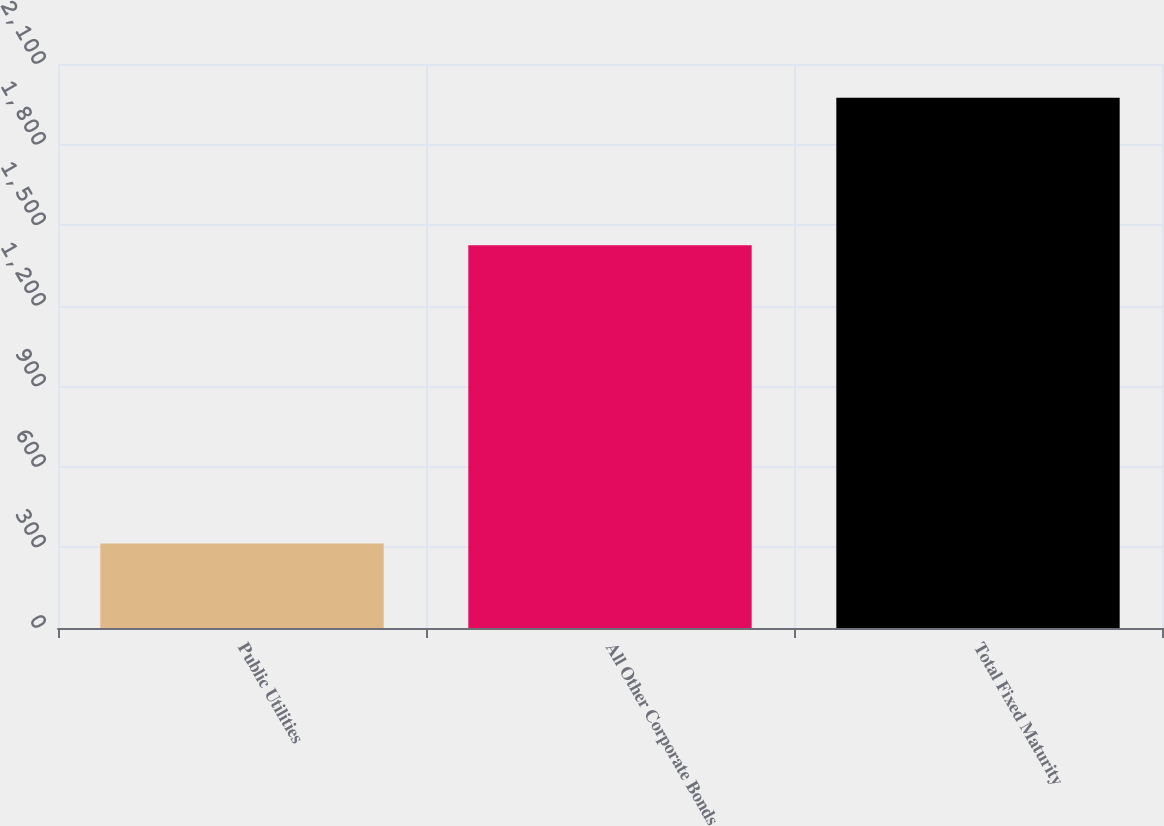<chart> <loc_0><loc_0><loc_500><loc_500><bar_chart><fcel>Public Utilities<fcel>All Other Corporate Bonds<fcel>Total Fixed Maturity<nl><fcel>315<fcel>1425.3<fcel>1974.6<nl></chart> 